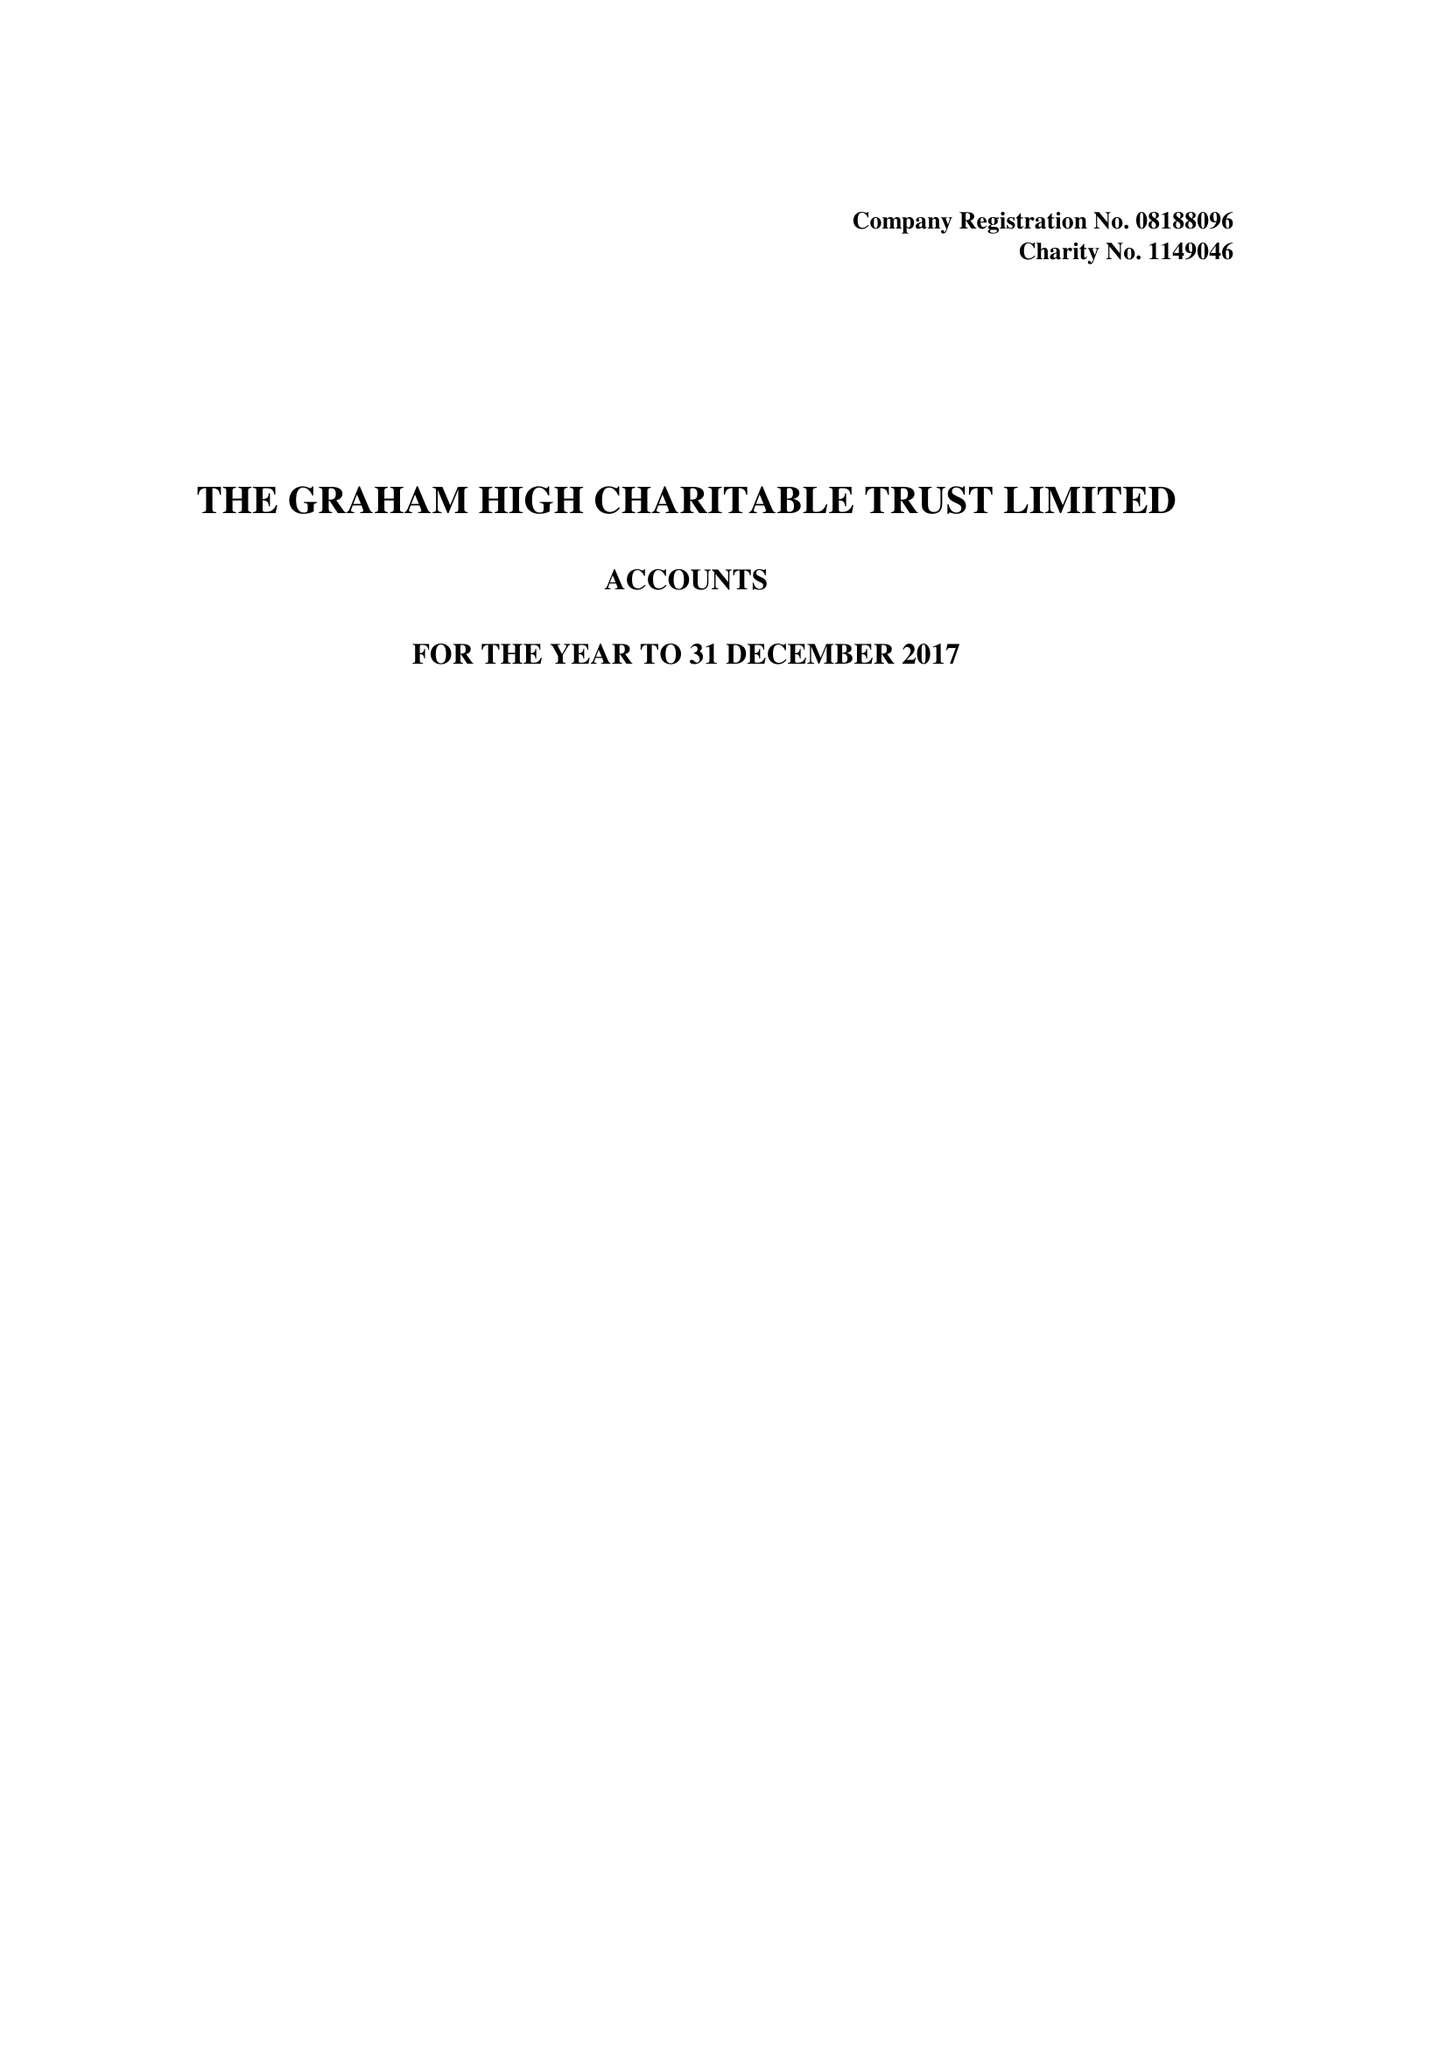What is the value for the spending_annually_in_british_pounds?
Answer the question using a single word or phrase. 14240.00 